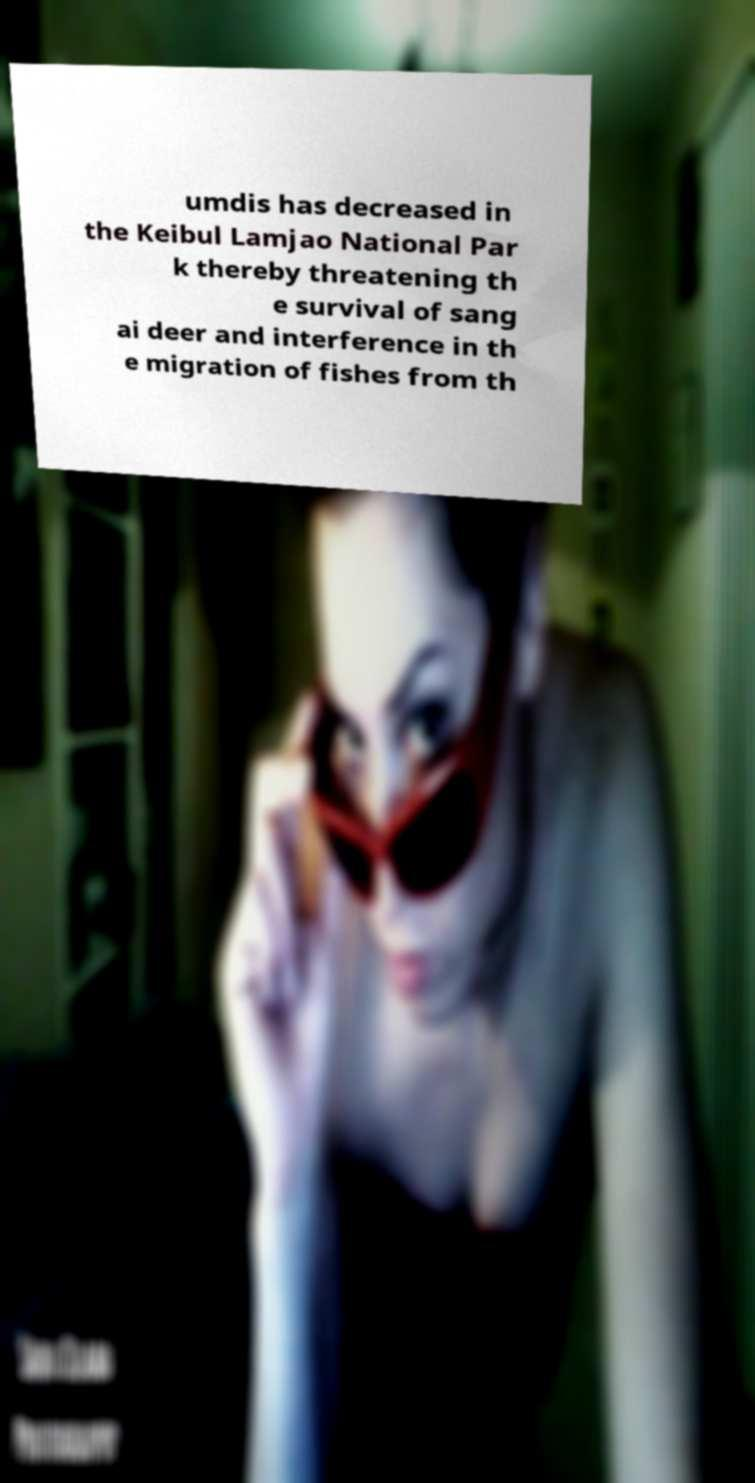Please read and relay the text visible in this image. What does it say? umdis has decreased in the Keibul Lamjao National Par k thereby threatening th e survival of sang ai deer and interference in th e migration of fishes from th 